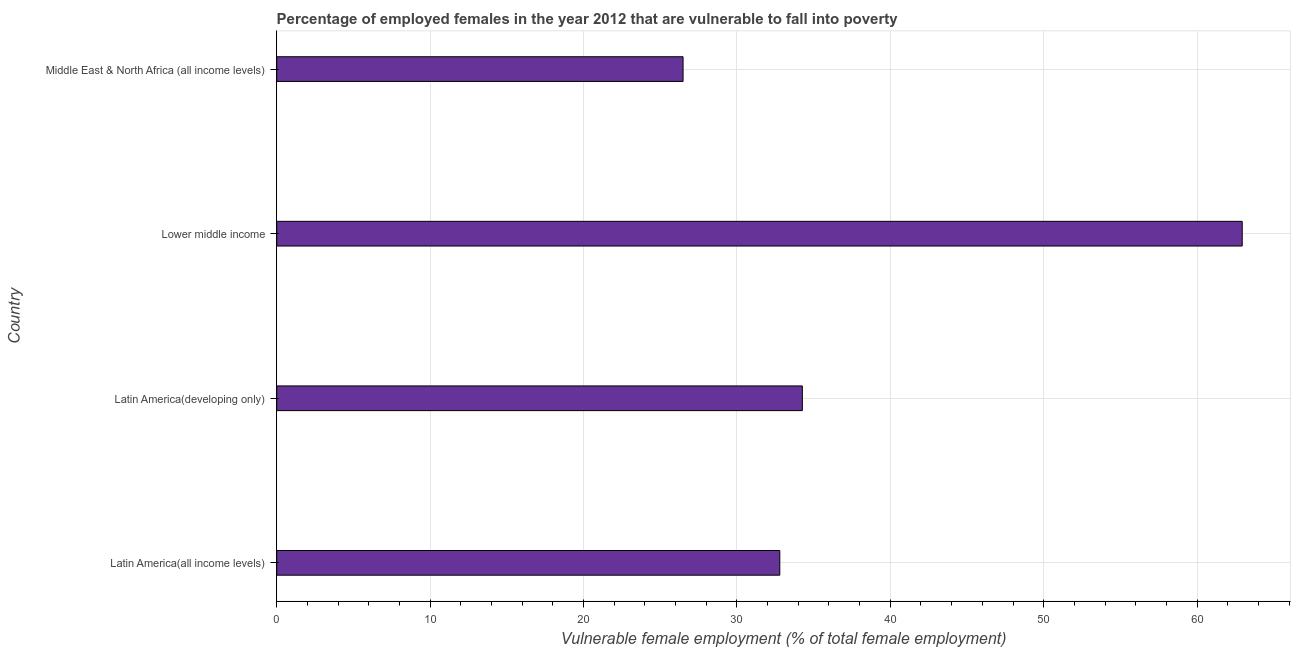Does the graph contain grids?
Keep it short and to the point. Yes. What is the title of the graph?
Offer a terse response. Percentage of employed females in the year 2012 that are vulnerable to fall into poverty. What is the label or title of the X-axis?
Provide a succinct answer. Vulnerable female employment (% of total female employment). What is the percentage of employed females who are vulnerable to fall into poverty in Latin America(developing only)?
Provide a succinct answer. 34.27. Across all countries, what is the maximum percentage of employed females who are vulnerable to fall into poverty?
Make the answer very short. 62.94. Across all countries, what is the minimum percentage of employed females who are vulnerable to fall into poverty?
Give a very brief answer. 26.49. In which country was the percentage of employed females who are vulnerable to fall into poverty maximum?
Your response must be concise. Lower middle income. In which country was the percentage of employed females who are vulnerable to fall into poverty minimum?
Offer a terse response. Middle East & North Africa (all income levels). What is the sum of the percentage of employed females who are vulnerable to fall into poverty?
Offer a very short reply. 156.5. What is the difference between the percentage of employed females who are vulnerable to fall into poverty in Latin America(developing only) and Middle East & North Africa (all income levels)?
Make the answer very short. 7.78. What is the average percentage of employed females who are vulnerable to fall into poverty per country?
Provide a short and direct response. 39.12. What is the median percentage of employed females who are vulnerable to fall into poverty?
Give a very brief answer. 33.53. In how many countries, is the percentage of employed females who are vulnerable to fall into poverty greater than 10 %?
Your answer should be compact. 4. What is the ratio of the percentage of employed females who are vulnerable to fall into poverty in Latin America(developing only) to that in Middle East & North Africa (all income levels)?
Offer a terse response. 1.29. Is the percentage of employed females who are vulnerable to fall into poverty in Latin America(developing only) less than that in Middle East & North Africa (all income levels)?
Your answer should be compact. No. What is the difference between the highest and the second highest percentage of employed females who are vulnerable to fall into poverty?
Your answer should be compact. 28.68. Is the sum of the percentage of employed females who are vulnerable to fall into poverty in Lower middle income and Middle East & North Africa (all income levels) greater than the maximum percentage of employed females who are vulnerable to fall into poverty across all countries?
Your answer should be compact. Yes. What is the difference between the highest and the lowest percentage of employed females who are vulnerable to fall into poverty?
Give a very brief answer. 36.45. In how many countries, is the percentage of employed females who are vulnerable to fall into poverty greater than the average percentage of employed females who are vulnerable to fall into poverty taken over all countries?
Ensure brevity in your answer.  1. How many bars are there?
Your response must be concise. 4. What is the difference between two consecutive major ticks on the X-axis?
Make the answer very short. 10. Are the values on the major ticks of X-axis written in scientific E-notation?
Provide a short and direct response. No. What is the Vulnerable female employment (% of total female employment) of Latin America(all income levels)?
Provide a succinct answer. 32.8. What is the Vulnerable female employment (% of total female employment) in Latin America(developing only)?
Your answer should be very brief. 34.27. What is the Vulnerable female employment (% of total female employment) in Lower middle income?
Offer a terse response. 62.94. What is the Vulnerable female employment (% of total female employment) of Middle East & North Africa (all income levels)?
Ensure brevity in your answer.  26.49. What is the difference between the Vulnerable female employment (% of total female employment) in Latin America(all income levels) and Latin America(developing only)?
Ensure brevity in your answer.  -1.47. What is the difference between the Vulnerable female employment (% of total female employment) in Latin America(all income levels) and Lower middle income?
Offer a very short reply. -30.15. What is the difference between the Vulnerable female employment (% of total female employment) in Latin America(all income levels) and Middle East & North Africa (all income levels)?
Offer a terse response. 6.31. What is the difference between the Vulnerable female employment (% of total female employment) in Latin America(developing only) and Lower middle income?
Keep it short and to the point. -28.68. What is the difference between the Vulnerable female employment (% of total female employment) in Latin America(developing only) and Middle East & North Africa (all income levels)?
Give a very brief answer. 7.78. What is the difference between the Vulnerable female employment (% of total female employment) in Lower middle income and Middle East & North Africa (all income levels)?
Make the answer very short. 36.45. What is the ratio of the Vulnerable female employment (% of total female employment) in Latin America(all income levels) to that in Latin America(developing only)?
Give a very brief answer. 0.96. What is the ratio of the Vulnerable female employment (% of total female employment) in Latin America(all income levels) to that in Lower middle income?
Ensure brevity in your answer.  0.52. What is the ratio of the Vulnerable female employment (% of total female employment) in Latin America(all income levels) to that in Middle East & North Africa (all income levels)?
Provide a succinct answer. 1.24. What is the ratio of the Vulnerable female employment (% of total female employment) in Latin America(developing only) to that in Lower middle income?
Give a very brief answer. 0.54. What is the ratio of the Vulnerable female employment (% of total female employment) in Latin America(developing only) to that in Middle East & North Africa (all income levels)?
Make the answer very short. 1.29. What is the ratio of the Vulnerable female employment (% of total female employment) in Lower middle income to that in Middle East & North Africa (all income levels)?
Give a very brief answer. 2.38. 